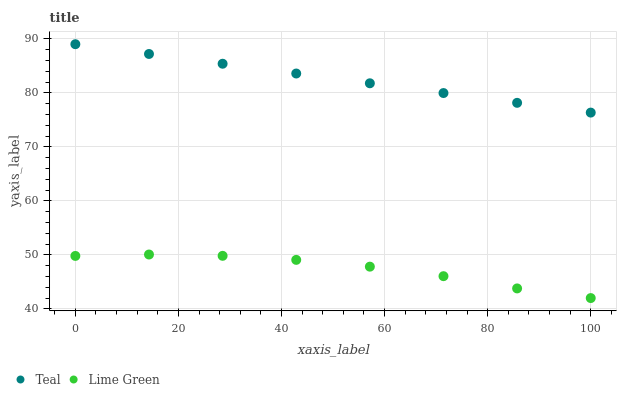Does Lime Green have the minimum area under the curve?
Answer yes or no. Yes. Does Teal have the maximum area under the curve?
Answer yes or no. Yes. Does Teal have the minimum area under the curve?
Answer yes or no. No. Is Teal the smoothest?
Answer yes or no. Yes. Is Lime Green the roughest?
Answer yes or no. Yes. Is Teal the roughest?
Answer yes or no. No. Does Lime Green have the lowest value?
Answer yes or no. Yes. Does Teal have the lowest value?
Answer yes or no. No. Does Teal have the highest value?
Answer yes or no. Yes. Is Lime Green less than Teal?
Answer yes or no. Yes. Is Teal greater than Lime Green?
Answer yes or no. Yes. Does Lime Green intersect Teal?
Answer yes or no. No. 